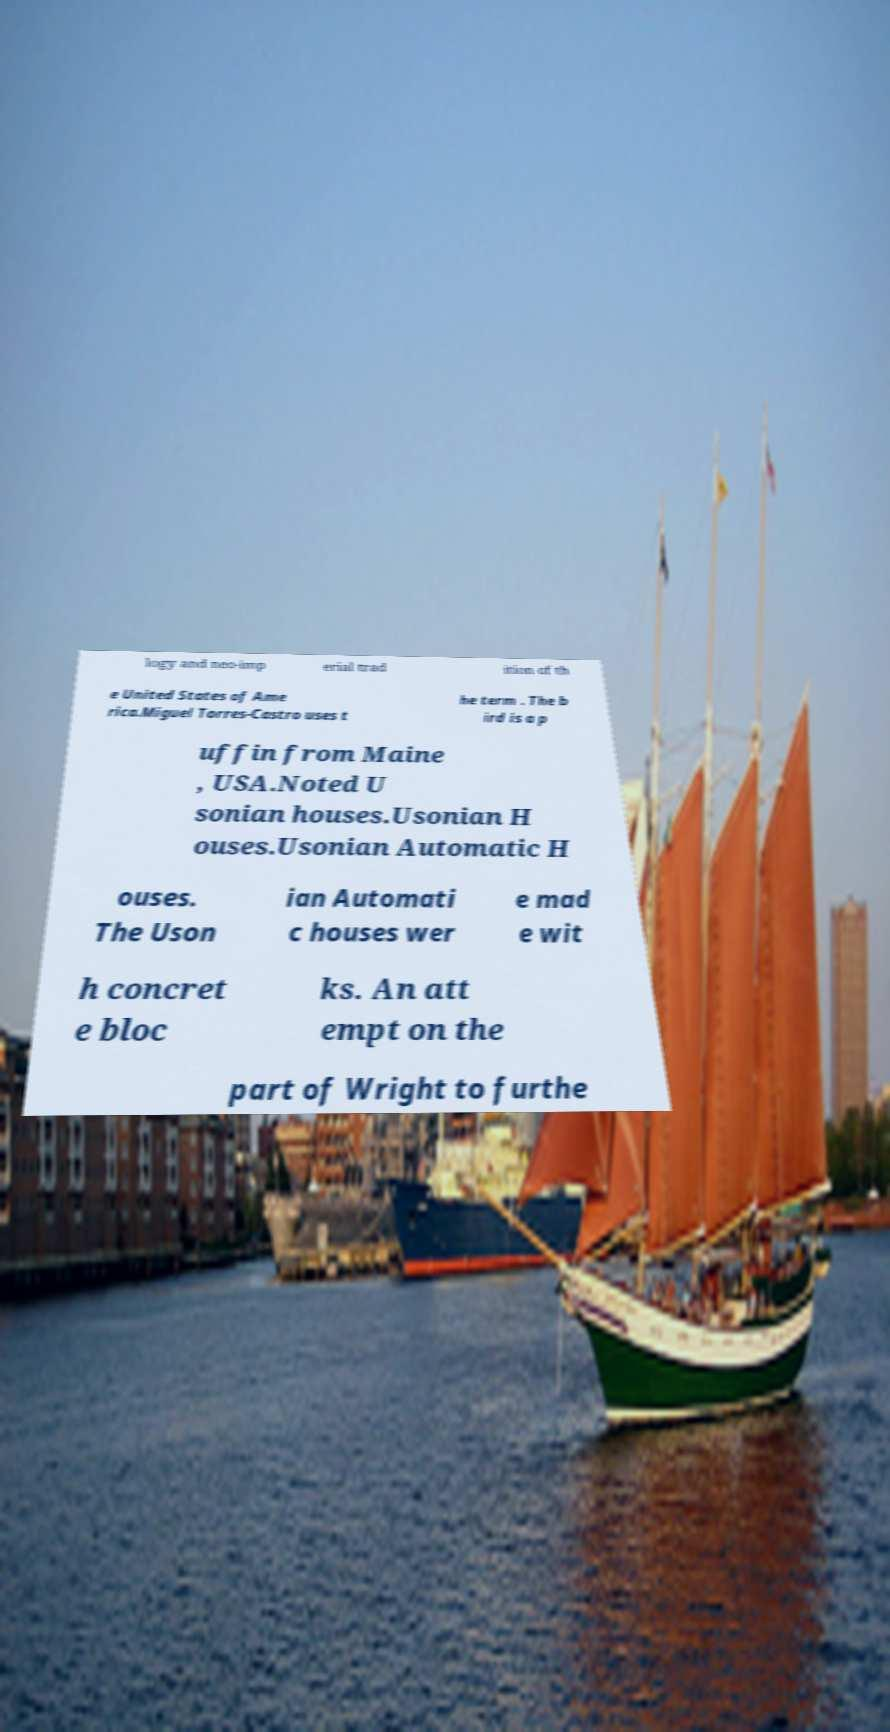Can you accurately transcribe the text from the provided image for me? logy and neo-imp erial trad ition of th e United States of Ame rica.Miguel Torres-Castro uses t he term . The b ird is a p uffin from Maine , USA.Noted U sonian houses.Usonian H ouses.Usonian Automatic H ouses. The Uson ian Automati c houses wer e mad e wit h concret e bloc ks. An att empt on the part of Wright to furthe 